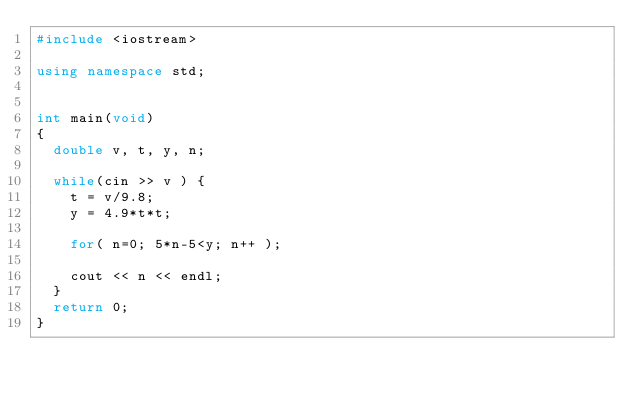Convert code to text. <code><loc_0><loc_0><loc_500><loc_500><_C++_>#include <iostream>

using namespace std;


int main(void)
{
	double v, t, y, n;

	while(cin >> v ) {
		t = v/9.8;
		y = 4.9*t*t;

		for( n=0; 5*n-5<y; n++ );

		cout << n << endl;
	}
	return 0;
}</code> 